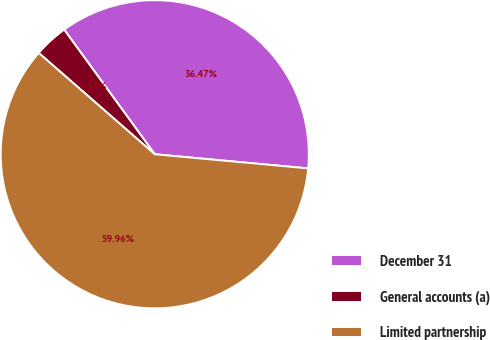Convert chart to OTSL. <chart><loc_0><loc_0><loc_500><loc_500><pie_chart><fcel>December 31<fcel>General accounts (a)<fcel>Limited partnership<nl><fcel>36.47%<fcel>3.57%<fcel>59.96%<nl></chart> 